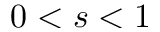Convert formula to latex. <formula><loc_0><loc_0><loc_500><loc_500>0 < s < 1</formula> 